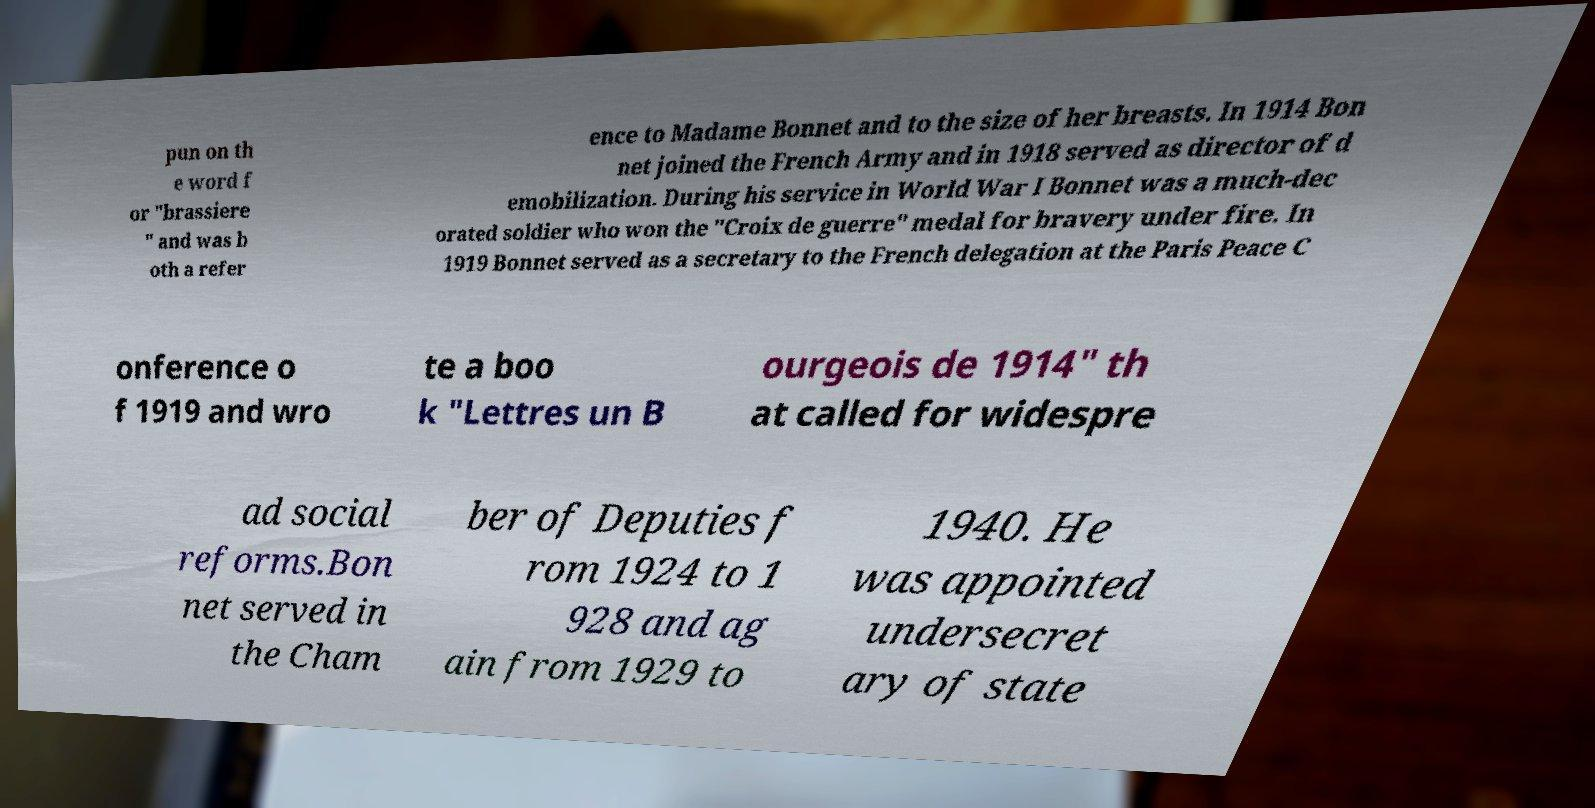I need the written content from this picture converted into text. Can you do that? pun on th e word f or "brassiere " and was b oth a refer ence to Madame Bonnet and to the size of her breasts. In 1914 Bon net joined the French Army and in 1918 served as director of d emobilization. During his service in World War I Bonnet was a much-dec orated soldier who won the "Croix de guerre" medal for bravery under fire. In 1919 Bonnet served as a secretary to the French delegation at the Paris Peace C onference o f 1919 and wro te a boo k "Lettres un B ourgeois de 1914" th at called for widespre ad social reforms.Bon net served in the Cham ber of Deputies f rom 1924 to 1 928 and ag ain from 1929 to 1940. He was appointed undersecret ary of state 